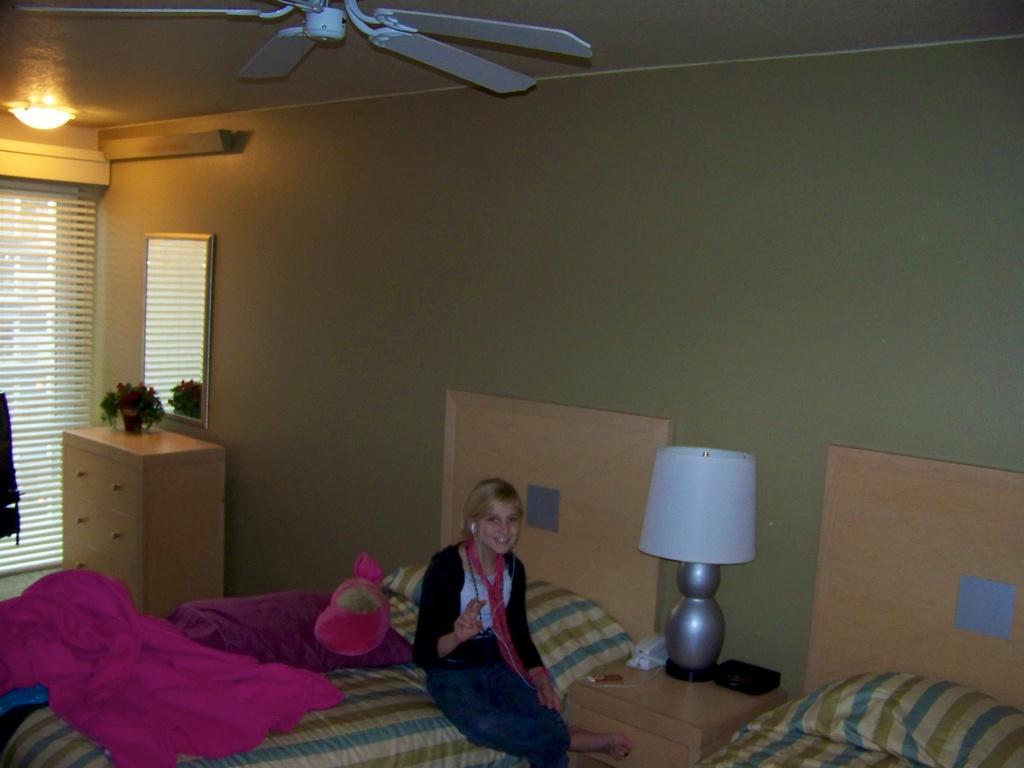In one or two sentences, can you explain what this image depicts? In this picture there is a bed. On the bed there is a pink blanket and a pillow. And a lady with black shirt is sitting on the bed. Beside the bed there is a table with lamp and a black box. In the left corner there is a window. On the top there is a light. On the cupboard there is a flower vase. In front of the flower vase there is a mirror. On the top there is a fan. 